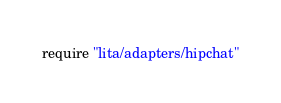<code> <loc_0><loc_0><loc_500><loc_500><_Ruby_>require "lita/adapters/hipchat"
</code> 